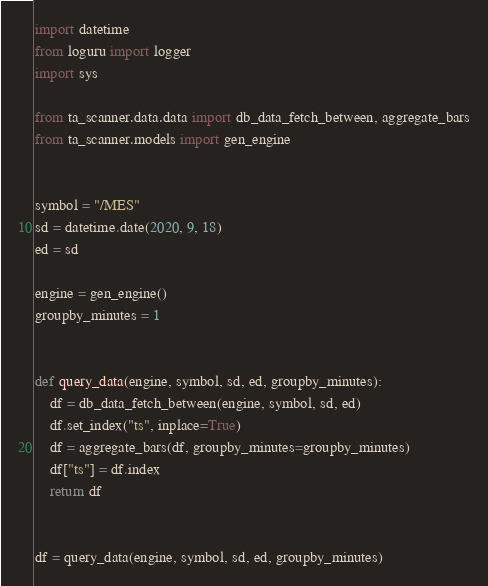Convert code to text. <code><loc_0><loc_0><loc_500><loc_500><_Python_>import datetime
from loguru import logger
import sys

from ta_scanner.data.data import db_data_fetch_between, aggregate_bars
from ta_scanner.models import gen_engine


symbol = "/MES"
sd = datetime.date(2020, 9, 18)
ed = sd

engine = gen_engine()
groupby_minutes = 1


def query_data(engine, symbol, sd, ed, groupby_minutes):
    df = db_data_fetch_between(engine, symbol, sd, ed)
    df.set_index("ts", inplace=True)
    df = aggregate_bars(df, groupby_minutes=groupby_minutes)
    df["ts"] = df.index
    return df


df = query_data(engine, symbol, sd, ed, groupby_minutes)</code> 